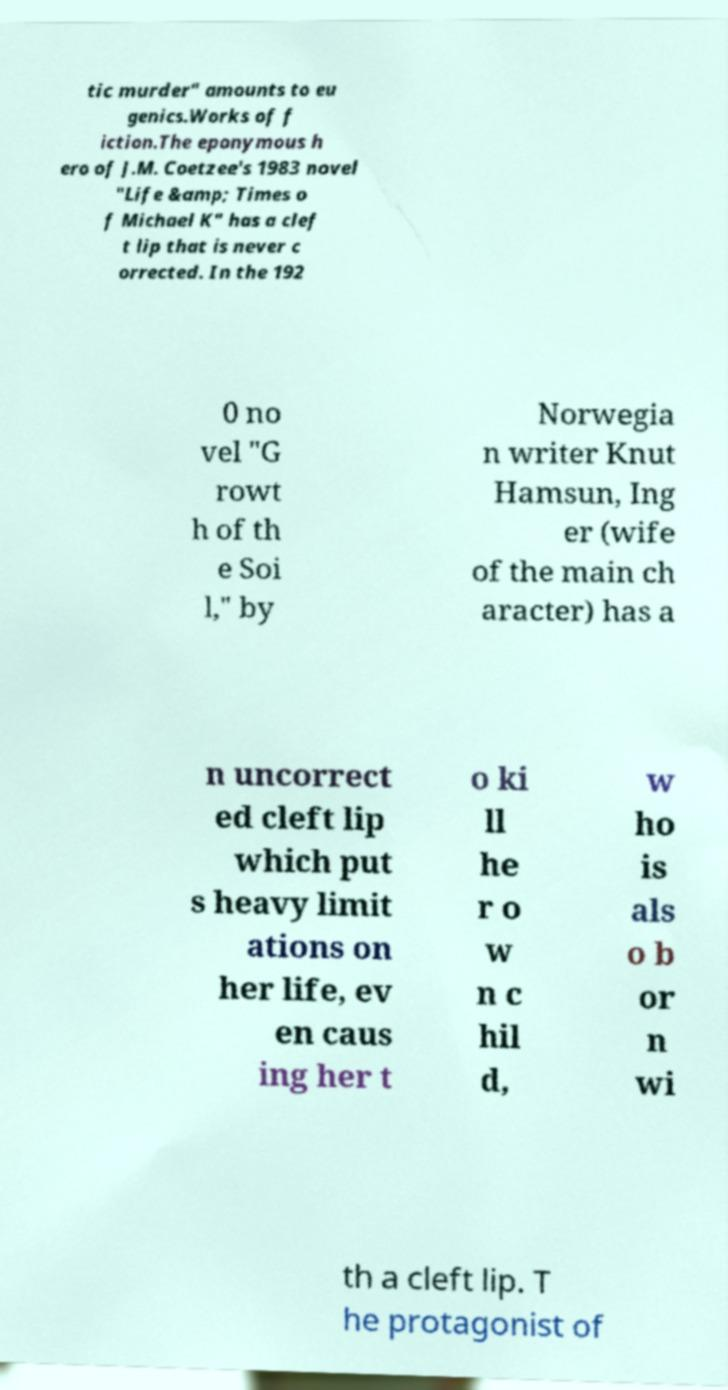For documentation purposes, I need the text within this image transcribed. Could you provide that? tic murder" amounts to eu genics.Works of f iction.The eponymous h ero of J.M. Coetzee's 1983 novel "Life &amp; Times o f Michael K" has a clef t lip that is never c orrected. In the 192 0 no vel "G rowt h of th e Soi l," by Norwegia n writer Knut Hamsun, Ing er (wife of the main ch aracter) has a n uncorrect ed cleft lip which put s heavy limit ations on her life, ev en caus ing her t o ki ll he r o w n c hil d, w ho is als o b or n wi th a cleft lip. T he protagonist of 